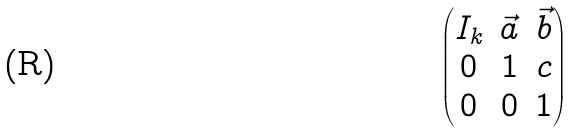Convert formula to latex. <formula><loc_0><loc_0><loc_500><loc_500>\begin{pmatrix} I _ { k } & \vec { a } & \vec { b } \\ 0 & 1 & c \\ 0 & 0 & 1 \end{pmatrix}</formula> 